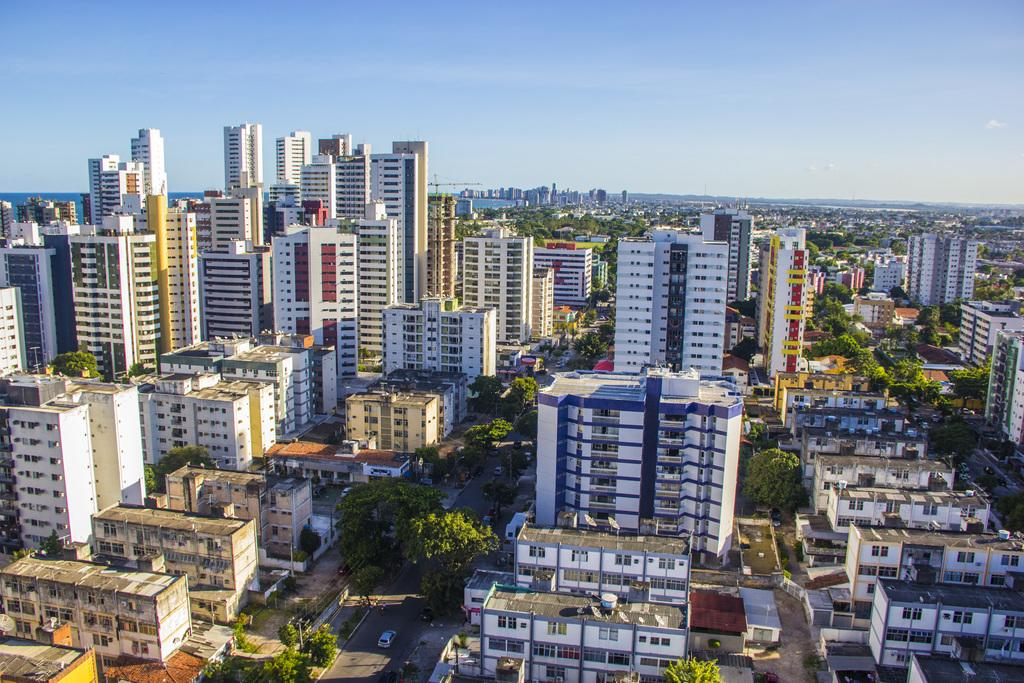What type of structures can be seen in the image? There are buildings in the image. What type of vegetation is present in the image? There are trees in the image. What is visible at the top of the image? The sky is visible at the top of the image. What type of attack is being carried out by the nation in the image? There is no indication of an attack or any nation in the image; it features buildings and trees. Can you tell me the name of the father of the person in the image? There is no person present in the image, so it is not possible to determine the name of their father. 